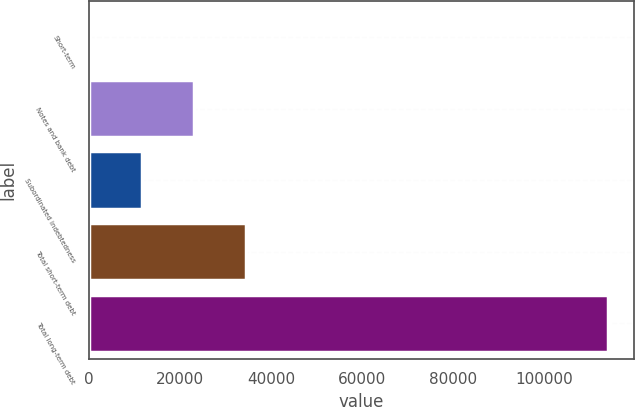<chart> <loc_0><loc_0><loc_500><loc_500><bar_chart><fcel>Short-term<fcel>Notes and bank debt<fcel>Subordinated indebtedness<fcel>Total short-term debt<fcel>Total long-term debt<nl><fcel>270<fcel>23014.4<fcel>11642.2<fcel>34386.6<fcel>113992<nl></chart> 